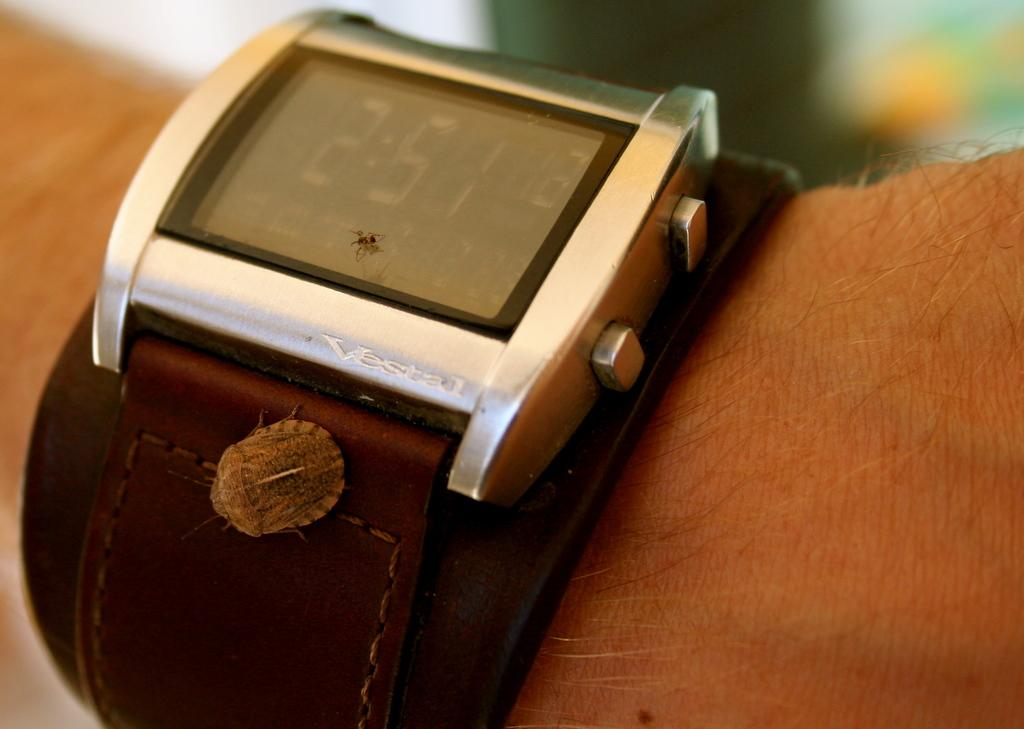What object is visible on a person's hand in the image? There is a wrist watch on a person's hand in the image. What is the purpose of the wrist watch? The wrist watch is used for telling time. Are there any other elements present on the wrist watch? Yes, there are insects on the wrist watch. What number is written on the person's ear in the image? There is no number written on the person's ear in the image. 